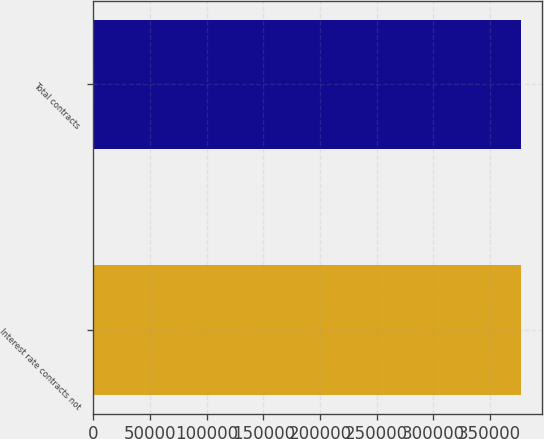Convert chart. <chart><loc_0><loc_0><loc_500><loc_500><bar_chart><fcel>Interest rate contracts not<fcel>Total contracts<nl><fcel>377249<fcel>377249<nl></chart> 